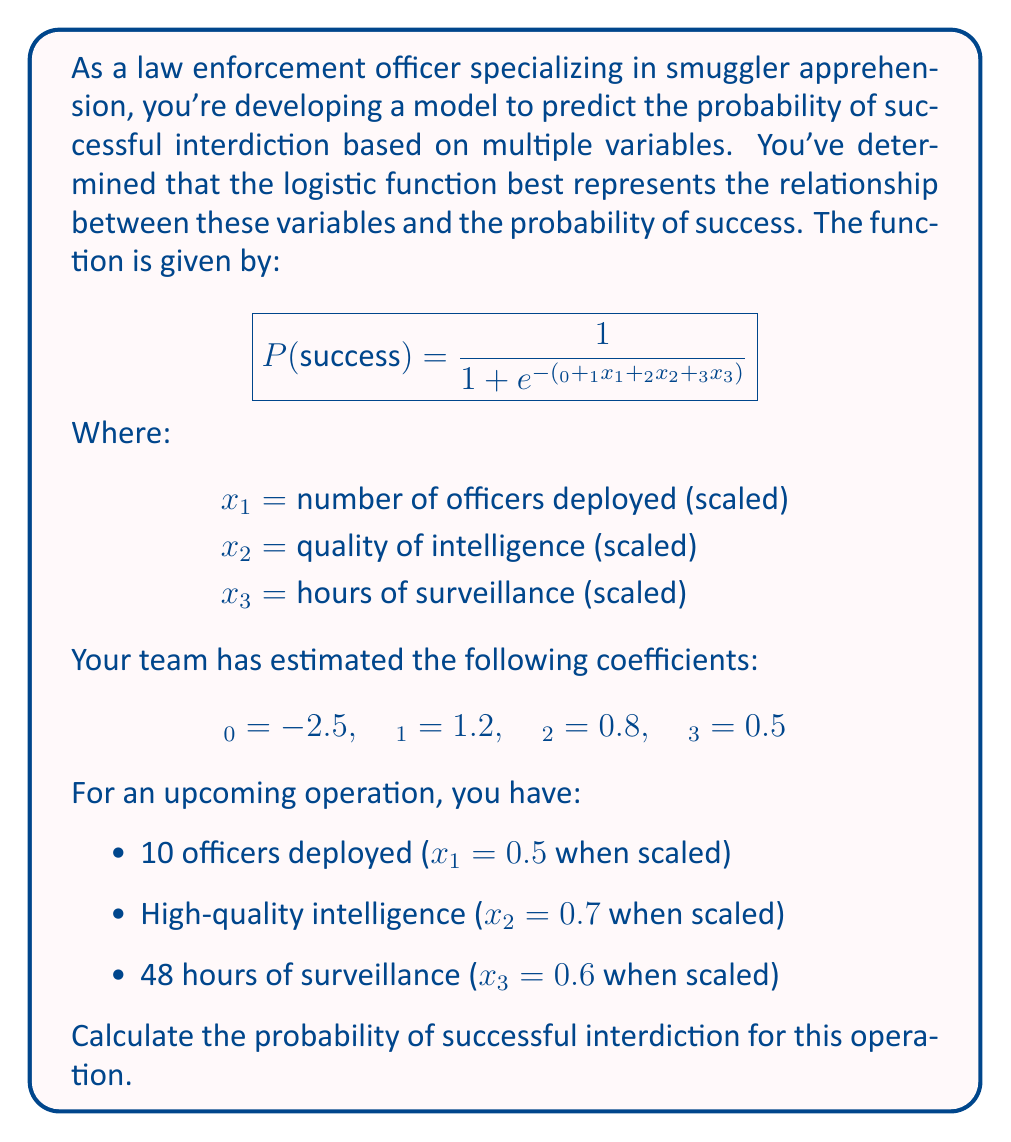Can you answer this question? To solve this problem, we'll follow these steps:

1) First, let's recall the logistic function for the probability of success:

   $$P(success) = \frac{1}{1 + e^{-(β_0 + β_1x_1 + β_2x_2 + β_3x_3)}}$$

2) We're given the following values:
   $β_0 = -2.5$, $β_1 = 1.2$, $β_2 = 0.8$, $β_3 = 0.5$
   $x_1 = 0.5$, $x_2 = 0.7$, $x_3 = 0.6$

3) Let's substitute these values into the equation inside the exponential:

   $β_0 + β_1x_1 + β_2x_2 + β_3x_3$
   $= -2.5 + 1.2(0.5) + 0.8(0.7) + 0.5(0.6)$
   $= -2.5 + 0.6 + 0.56 + 0.3$
   $= -1.04$

4) Now our probability equation looks like this:

   $$P(success) = \frac{1}{1 + e^{1.04}}$$

5) Let's calculate $e^{1.04}$:
   $e^{1.04} \approx 2.8289$

6) Substituting this back into our equation:

   $$P(success) = \frac{1}{1 + 2.8289} = \frac{1}{3.8289}$$

7) Finally, let's calculate this fraction:

   $\frac{1}{3.8289} \approx 0.2612$

Therefore, the probability of successful interdiction for this operation is approximately 0.2612 or 26.12%.
Answer: The probability of successful interdiction is approximately 0.2612 or 26.12%. 